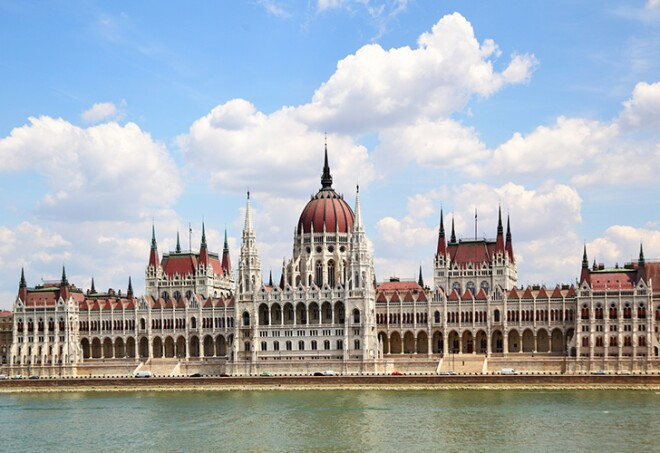Explain the visual content of the image in great detail. The image showcases the majestic Hungarian Parliament Building, an iconic landmark situated in Budapest, Hungary. This architectural gem, completed in 1904, is celebrated for its neo-Gothic design, though it also features Renaissance and Baroque details. Central to its appearance is the large, central dome, which is strikingly red and provides a stark contrast to the gray and white stone facade of the building. The building's façade is richly adorned with statues, intricate carvings, and pointed spires that add to its grandeur. Positioned along the serene banks of the Danube River, the building stretches out in a symmetric, linear fashion, reflecting beautifully in the water. The clear, blue sky above, dotted with fluffy white clouds, further enhances the picturesque nature of the scene. In this comprehensive view, the surrounding greenery, the river, and the sky come together to highlight the architectural brilliance and historical significance of this distinguished edifice in Budapest's cityscape. 